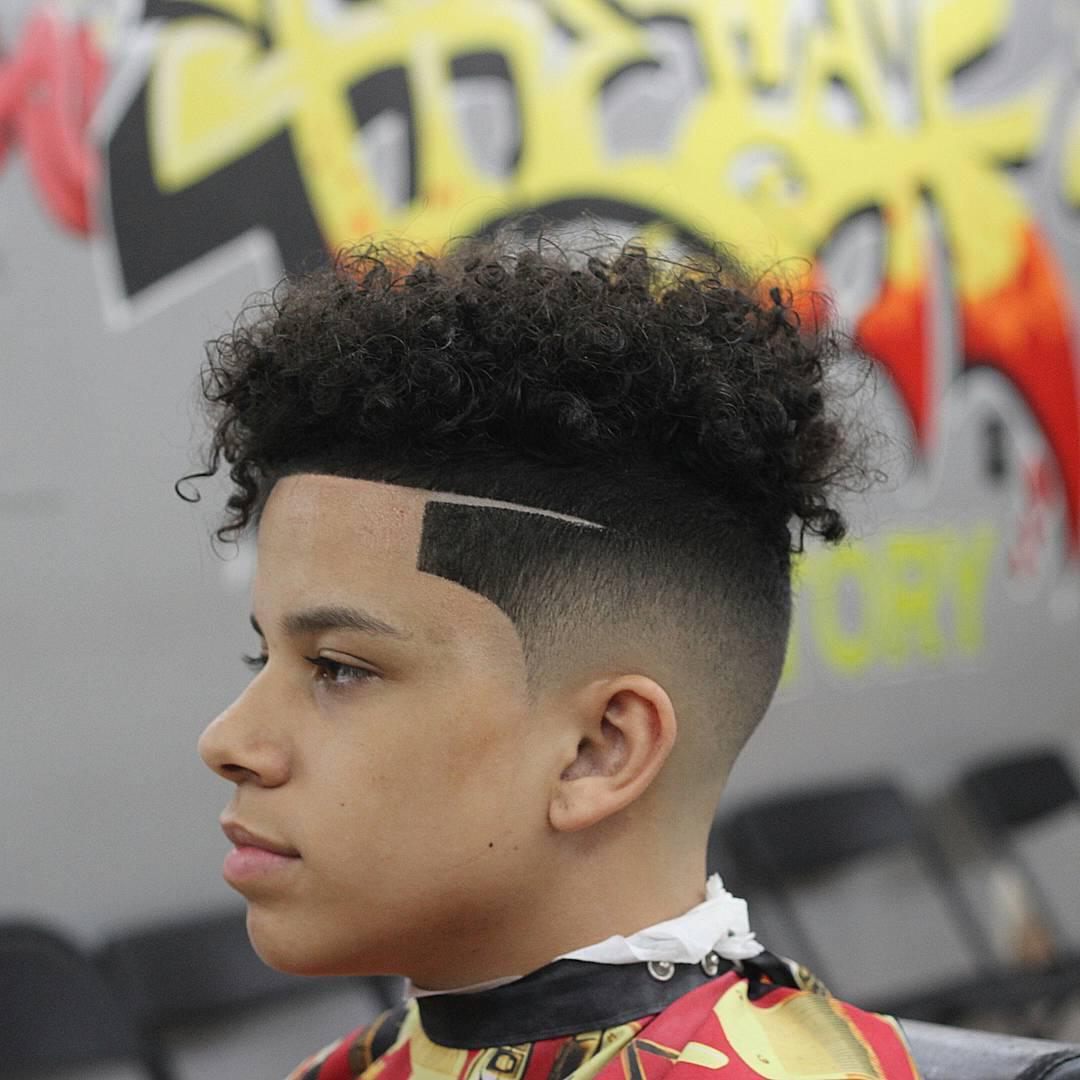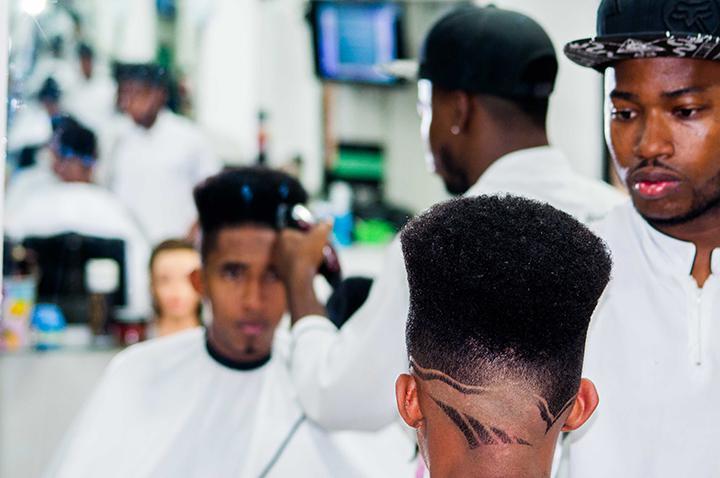The first image is the image on the left, the second image is the image on the right. Evaluate the accuracy of this statement regarding the images: "The left image shows a leftward-facing male with no beard on his chin and a haircut that creates an unbroken right angle on the side.". Is it true? Answer yes or no. No. 